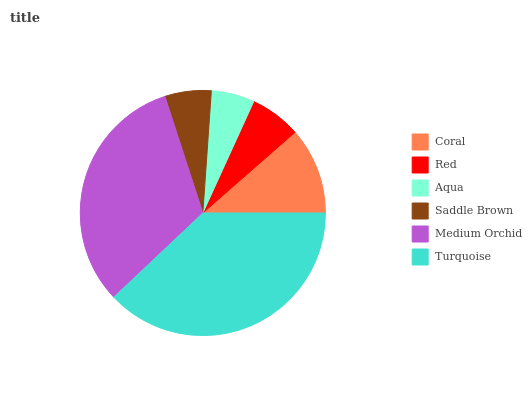Is Aqua the minimum?
Answer yes or no. Yes. Is Turquoise the maximum?
Answer yes or no. Yes. Is Red the minimum?
Answer yes or no. No. Is Red the maximum?
Answer yes or no. No. Is Coral greater than Red?
Answer yes or no. Yes. Is Red less than Coral?
Answer yes or no. Yes. Is Red greater than Coral?
Answer yes or no. No. Is Coral less than Red?
Answer yes or no. No. Is Coral the high median?
Answer yes or no. Yes. Is Red the low median?
Answer yes or no. Yes. Is Saddle Brown the high median?
Answer yes or no. No. Is Saddle Brown the low median?
Answer yes or no. No. 